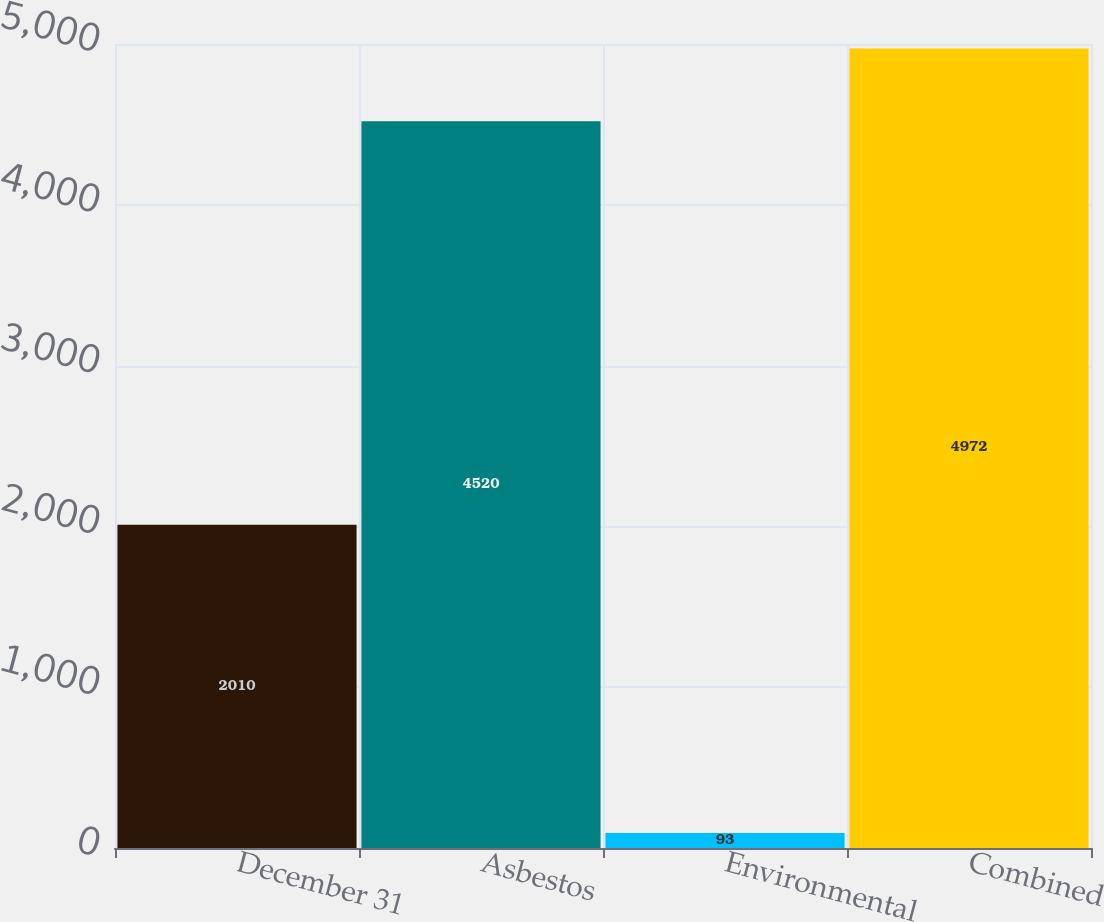Convert chart to OTSL. <chart><loc_0><loc_0><loc_500><loc_500><bar_chart><fcel>December 31<fcel>Asbestos<fcel>Environmental<fcel>Combined<nl><fcel>2010<fcel>4520<fcel>93<fcel>4972<nl></chart> 